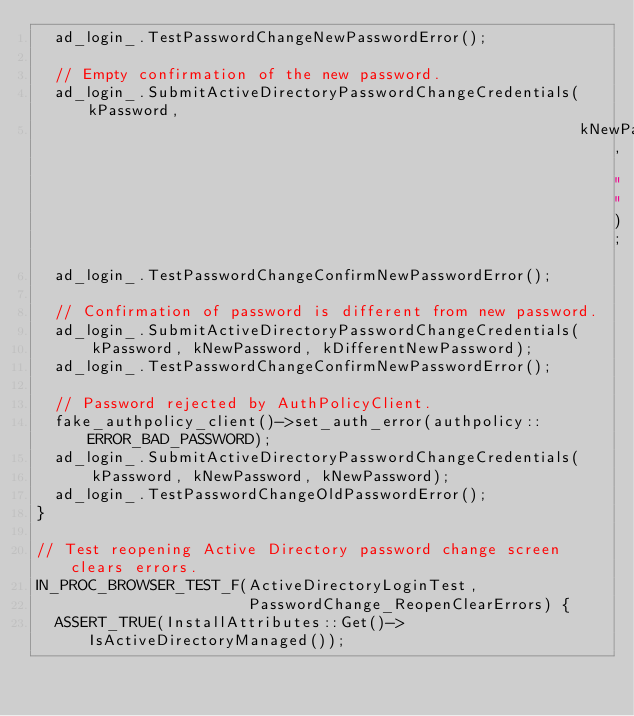<code> <loc_0><loc_0><loc_500><loc_500><_C++_>  ad_login_.TestPasswordChangeNewPasswordError();

  // Empty confirmation of the new password.
  ad_login_.SubmitActiveDirectoryPasswordChangeCredentials(kPassword,
                                                           kNewPassword, "");
  ad_login_.TestPasswordChangeConfirmNewPasswordError();

  // Confirmation of password is different from new password.
  ad_login_.SubmitActiveDirectoryPasswordChangeCredentials(
      kPassword, kNewPassword, kDifferentNewPassword);
  ad_login_.TestPasswordChangeConfirmNewPasswordError();

  // Password rejected by AuthPolicyClient.
  fake_authpolicy_client()->set_auth_error(authpolicy::ERROR_BAD_PASSWORD);
  ad_login_.SubmitActiveDirectoryPasswordChangeCredentials(
      kPassword, kNewPassword, kNewPassword);
  ad_login_.TestPasswordChangeOldPasswordError();
}

// Test reopening Active Directory password change screen clears errors.
IN_PROC_BROWSER_TEST_F(ActiveDirectoryLoginTest,
                       PasswordChange_ReopenClearErrors) {
  ASSERT_TRUE(InstallAttributes::Get()->IsActiveDirectoryManaged());</code> 